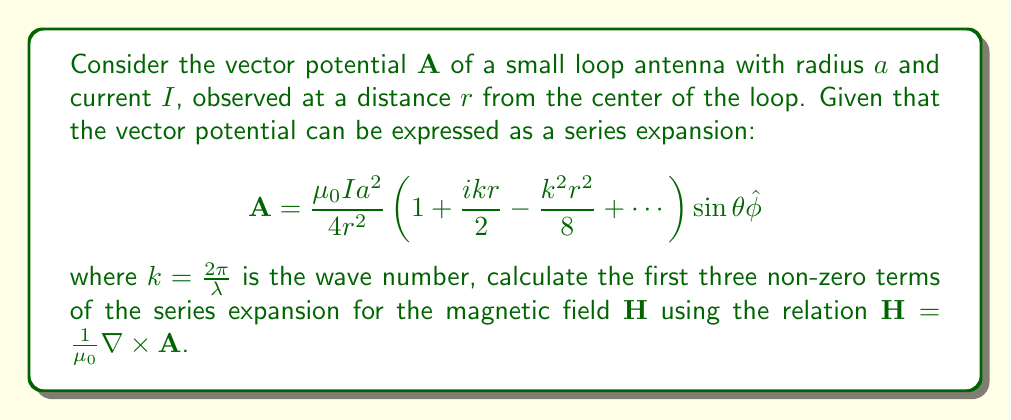Solve this math problem. To solve this problem, we'll follow these steps:

1) Recall that $\mathbf{H} = \frac{1}{\mu_0}\nabla \times \mathbf{A}$

2) The vector potential $\mathbf{A}$ is given in spherical coordinates. We need to apply the curl operator in spherical coordinates:

   $$\nabla \times \mathbf{A} = \frac{1}{r\sin\theta}\left(\frac{\partial}{\partial\theta}(A_\phi\sin\theta) - \frac{\partial A_\theta}{\partial\phi}\right)\hat{r} + \frac{1}{r}\left(\frac{1}{\sin\theta}\frac{\partial A_r}{\partial\phi} - \frac{\partial}{\partial r}(rA_\phi)\right)\hat{\theta} + \frac{1}{r}\left(\frac{\partial}{\partial r}(rA_\theta) - \frac{\partial A_r}{\partial\theta}\right)\hat{\phi}$$

3) In our case, $A_r = A_\theta = 0$ and $A_\phi = \frac{\mu_0 I a^2}{4r^2} \left(1 + \frac{ikr}{2} - \frac{k^2r^2}{8} + \cdots\right) \sin\theta$

4) Simplifying the curl equation with our $\mathbf{A}$:

   $$\nabla \times \mathbf{A} = \frac{1}{r\sin\theta}\frac{\partial}{\partial\theta}(A_\phi\sin\theta)\hat{r} - \frac{1}{r}\frac{\partial}{\partial r}(rA_\phi)\hat{\theta}$$

5) Let's calculate each component:

   For $\hat{r}$ component:
   $$\frac{1}{r\sin\theta}\frac{\partial}{\partial\theta}(A_\phi\sin\theta) = \frac{\mu_0 I a^2}{4r^3} \left(1 + \frac{ikr}{2} - \frac{k^2r^2}{8} + \cdots\right) 2\cos\theta$$

   For $\hat{\theta}$ component:
   $$-\frac{1}{r}\frac{\partial}{\partial r}(rA_\phi) = -\frac{\mu_0 I a^2}{4r^3} \left(1 + ikr - \frac{k^2r^2}{4} + \cdots\right) \sin\theta$$

6) Now, we can write $\mathbf{H}$:

   $$\mathbf{H} = \frac{I a^2}{4r^3} \left(1 + \frac{ikr}{2} - \frac{k^2r^2}{8} + \cdots\right) 2\cos\theta \hat{r} - \frac{I a^2}{4r^3} \left(1 + ikr - \frac{k^2r^2}{4} + \cdots\right) \sin\theta \hat{\theta}$$

7) Expanding and keeping only the first three non-zero terms:

   $$\mathbf{H} = \frac{I a^2}{2r^3} \left(1 + \frac{ikr}{2} - \frac{k^2r^2}{8}\right) \cos\theta \hat{r} - \frac{I a^2}{4r^3} \left(1 + ikr - \frac{k^2r^2}{4}\right) \sin\theta \hat{\theta}$$

This is the final expression for the magnetic field $\mathbf{H}$ with the first three non-zero terms of the series expansion.
Answer: $$\mathbf{H} = \frac{I a^2}{2r^3} \left(1 + \frac{ikr}{2} - \frac{k^2r^2}{8}\right) \cos\theta \hat{r} - \frac{I a^2}{4r^3} \left(1 + ikr - \frac{k^2r^2}{4}\right) \sin\theta \hat{\theta}$$ 